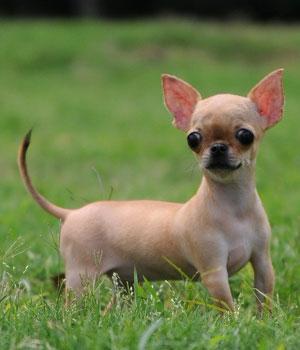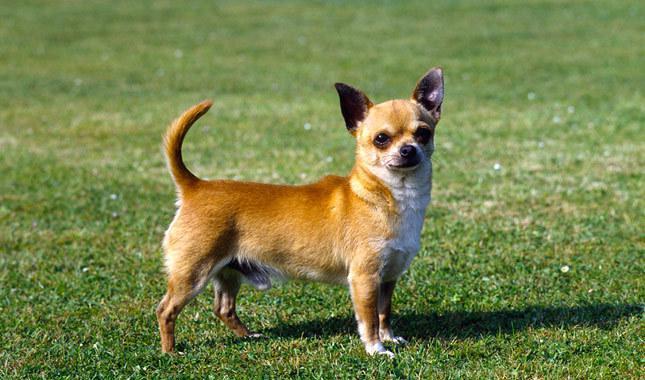The first image is the image on the left, the second image is the image on the right. For the images displayed, is the sentence "There are two chihuahuas with their heads to the right and tails up to the left." factually correct? Answer yes or no. Yes. 